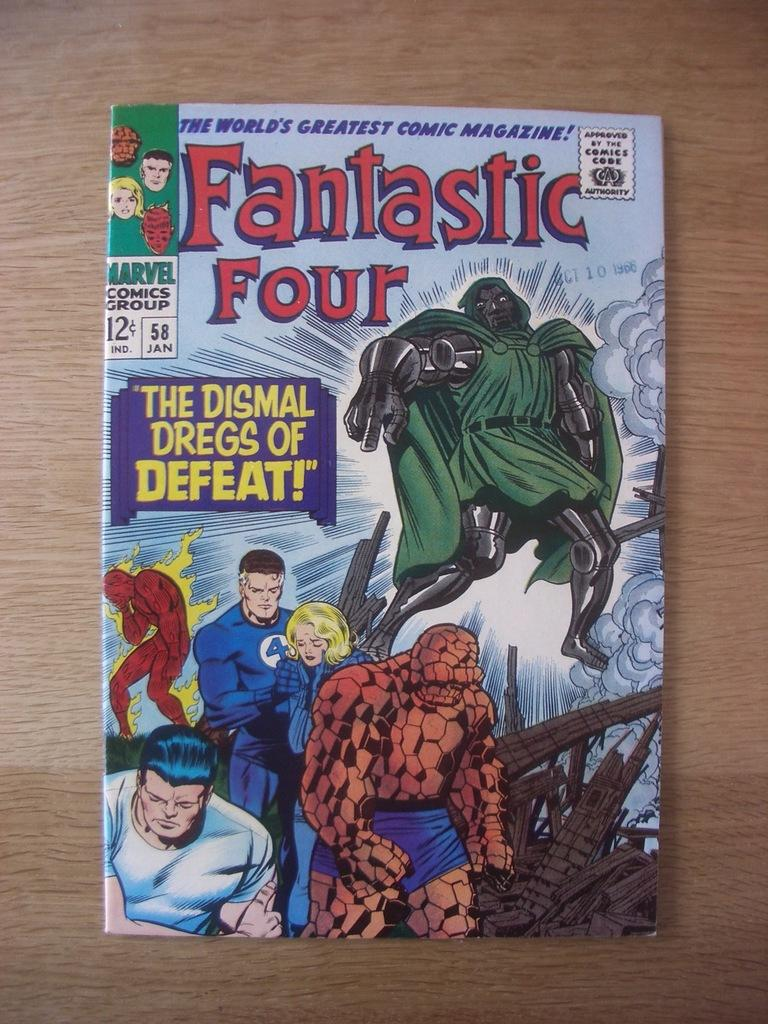<image>
Offer a succinct explanation of the picture presented. comic book called the fantastic four the dismal dregs 